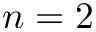<formula> <loc_0><loc_0><loc_500><loc_500>n = 2</formula> 